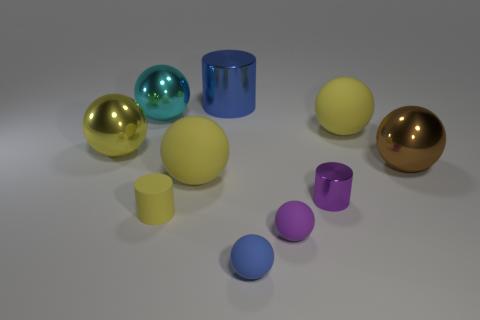Subtract all yellow balls. How many were subtracted if there are2yellow balls left? 1 Subtract all tiny spheres. How many spheres are left? 5 Subtract all gray blocks. How many yellow spheres are left? 3 Subtract all yellow spheres. How many spheres are left? 4 Subtract 5 balls. How many balls are left? 2 Subtract all blue balls. Subtract all purple cubes. How many balls are left? 6 Subtract 1 blue balls. How many objects are left? 9 Subtract all spheres. How many objects are left? 3 Subtract all brown metal things. Subtract all big matte spheres. How many objects are left? 7 Add 7 tiny metallic things. How many tiny metallic things are left? 8 